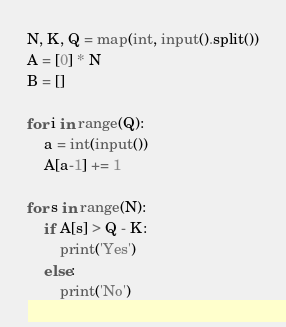<code> <loc_0><loc_0><loc_500><loc_500><_Python_>N, K, Q = map(int, input().split())
A = [0] * N
B = []

for i in range(Q):
    a = int(input())
    A[a-1] += 1

for s in range(N):
    if A[s] > Q - K:
        print('Yes')
    else:
        print('No')
</code> 